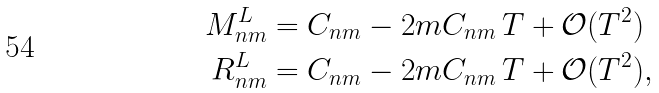<formula> <loc_0><loc_0><loc_500><loc_500>M _ { n m } ^ { L } & = C _ { n m } - 2 m C _ { n m } \, T + \mathcal { O } ( T ^ { 2 } ) \\ R _ { n m } ^ { L } & = C _ { n m } - 2 m C _ { n m } \, T + \mathcal { O } ( T ^ { 2 } ) ,</formula> 